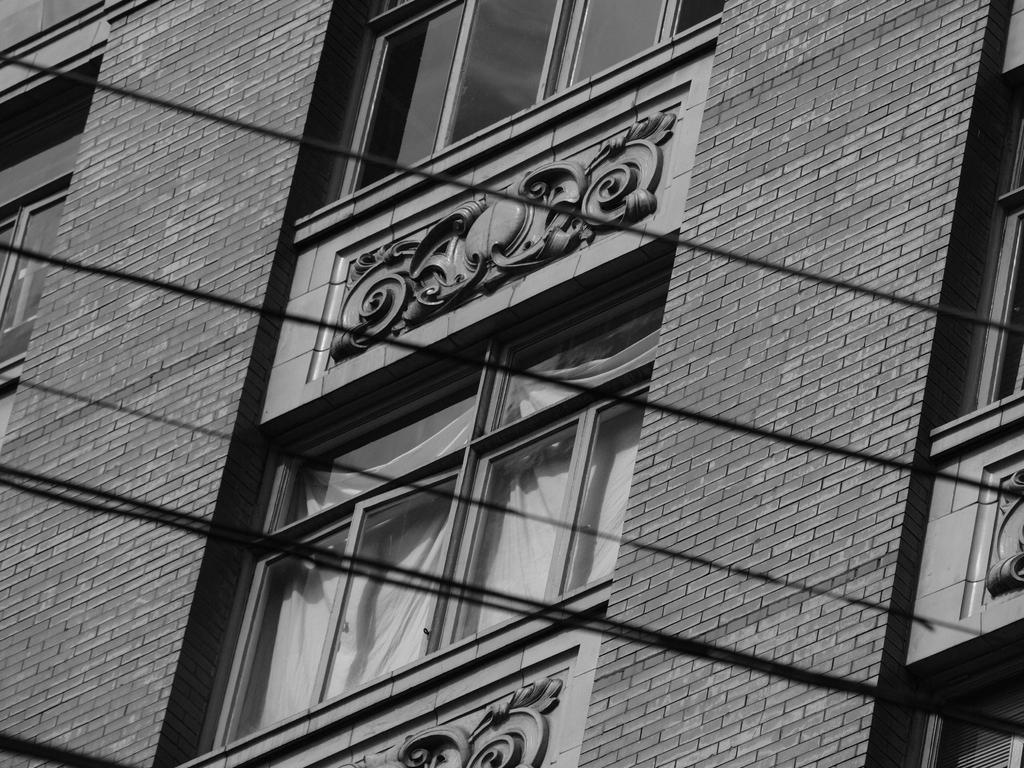What type of structure is visible in the image? There is a building in the image. What feature can be seen on the building? The building has windows. What type of window treatment is present in the image? There are white curtains in the image. What else is visible in the front of the image? There are wires in the front of the image. What is the name of the person standing next to the building in the image? There is no person standing next to the building in the image. How many hands are visible holding the curtains in the image? There are no hands visible holding the curtains in the image; the curtains are stationary. 